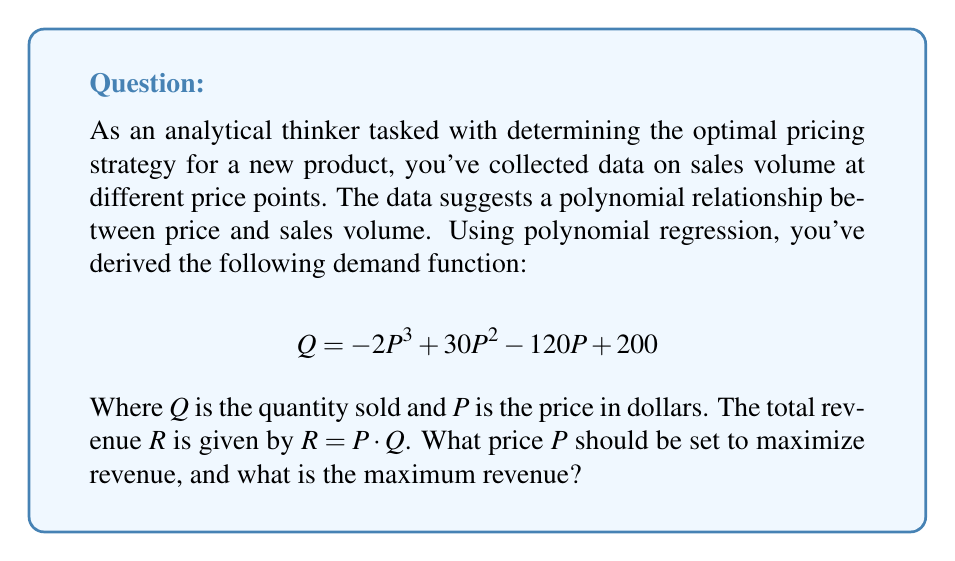Help me with this question. To solve this problem, we need to follow these steps:

1) First, we express the revenue function in terms of P:
   $$ R = P \cdot Q = P(-2P^3 + 30P^2 - 120P + 200) = -2P^4 + 30P^3 - 120P^2 + 200P $$

2) To find the maximum revenue, we need to find where the derivative of R with respect to P equals zero:
   $$ \frac{dR}{dP} = -8P^3 + 90P^2 - 240P + 200 $$

3) Set this equal to zero:
   $$ -8P^3 + 90P^2 - 240P + 200 = 0 $$

4) This is a cubic equation. We can solve it using the cubic formula or a graphing calculator. The solutions are approximately:
   $P = 2.5, 5, 10$

5) To determine which of these gives the maximum revenue (rather than a minimum or inflection point), we can check the second derivative or simply calculate the revenue at each point.

6) Calculating revenue at each point:
   At $P = 2.5$: $R = -2(2.5)^4 + 30(2.5)^3 - 120(2.5)^2 + 200(2.5) = 281.25$
   At $P = 5$: $R = -2(5)^4 + 30(5)^3 - 120(5)^2 + 200(5) = 625$
   At $P = 10$: $R = -2(10)^4 + 30(10)^3 - 120(10)^2 + 200(10) = 0$

7) The maximum revenue occurs at $P = 5$.
Answer: The optimal price to maximize revenue is $P = 5$, and the maximum revenue is $R = 625$. 